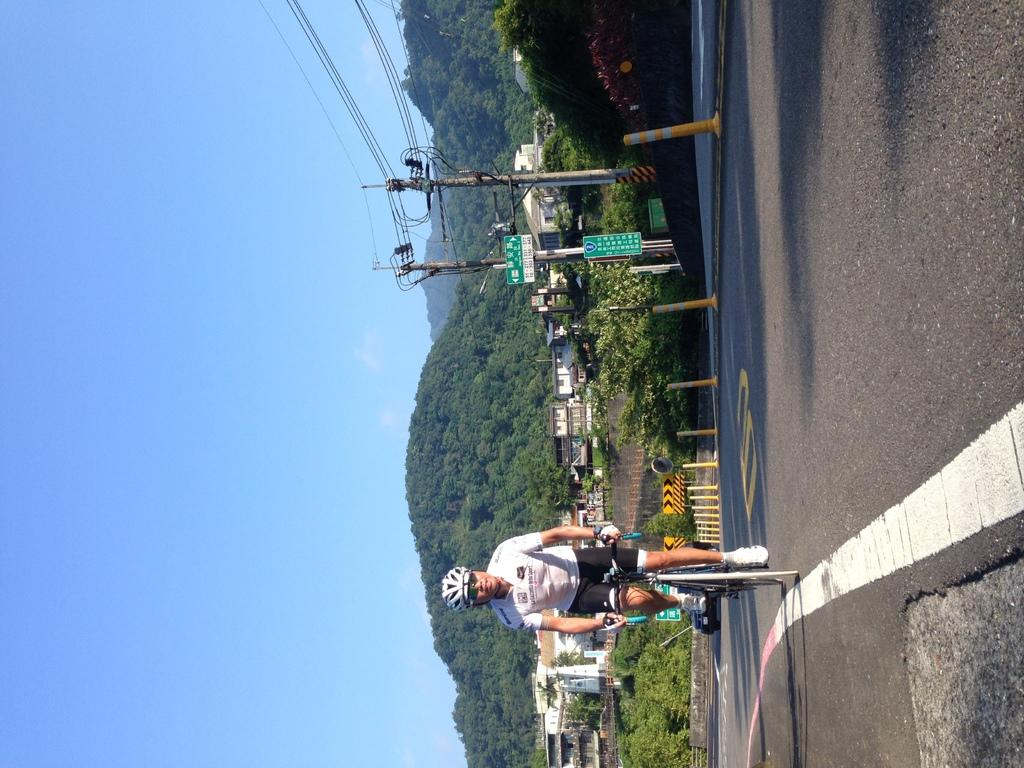What is the person in the image doing? There is a person riding a bicycle on the road in the image. What structures can be seen in the image? Poles, signboards, and buildings are visible in the image. What can be seen in the background of the image? Mountains and the sky are visible in the background of the image. What type of stamp can be seen on the person's back in the image? There is no stamp visible on the person's back in the image. What position is the person riding the bicycle in the image? The position of the person riding the bicycle cannot be determined from the image alone, as it only shows the person riding from the front. 